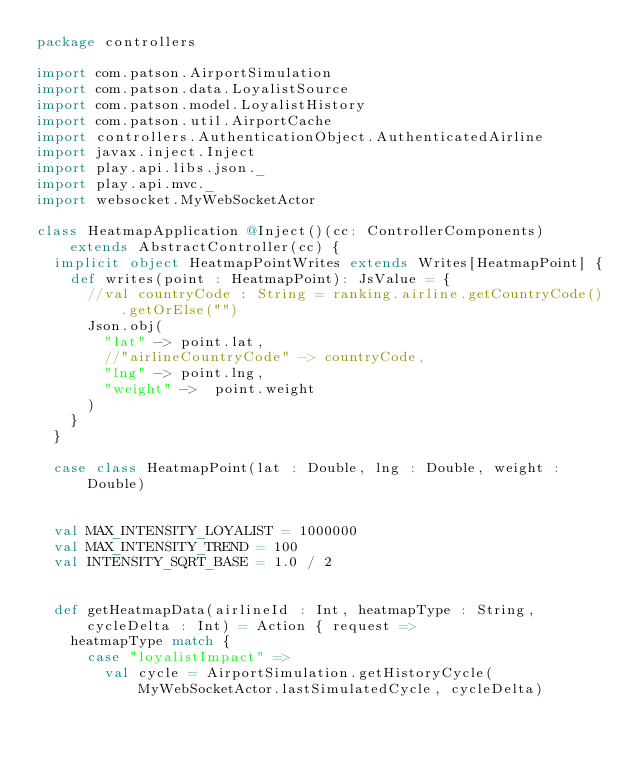<code> <loc_0><loc_0><loc_500><loc_500><_Scala_>package controllers

import com.patson.AirportSimulation
import com.patson.data.LoyalistSource
import com.patson.model.LoyalistHistory
import com.patson.util.AirportCache
import controllers.AuthenticationObject.AuthenticatedAirline
import javax.inject.Inject
import play.api.libs.json._
import play.api.mvc._
import websocket.MyWebSocketActor

class HeatmapApplication @Inject()(cc: ControllerComponents) extends AbstractController(cc) {
  implicit object HeatmapPointWrites extends Writes[HeatmapPoint] {
    def writes(point : HeatmapPoint): JsValue = {
      //val countryCode : String = ranking.airline.getCountryCode().getOrElse("")
      Json.obj(
        "lat" -> point.lat,
        //"airlineCountryCode" -> countryCode,
        "lng" -> point.lng,
        "weight" ->  point.weight
      )
    }
  }

  case class HeatmapPoint(lat : Double, lng : Double, weight : Double)


  val MAX_INTENSITY_LOYALIST = 1000000
  val MAX_INTENSITY_TREND = 100
  val INTENSITY_SQRT_BASE = 1.0 / 2


  def getHeatmapData(airlineId : Int, heatmapType : String, cycleDelta : Int) = Action { request =>
    heatmapType match {
      case "loyalistImpact" =>
        val cycle = AirportSimulation.getHistoryCycle(MyWebSocketActor.lastSimulatedCycle, cycleDelta)</code> 